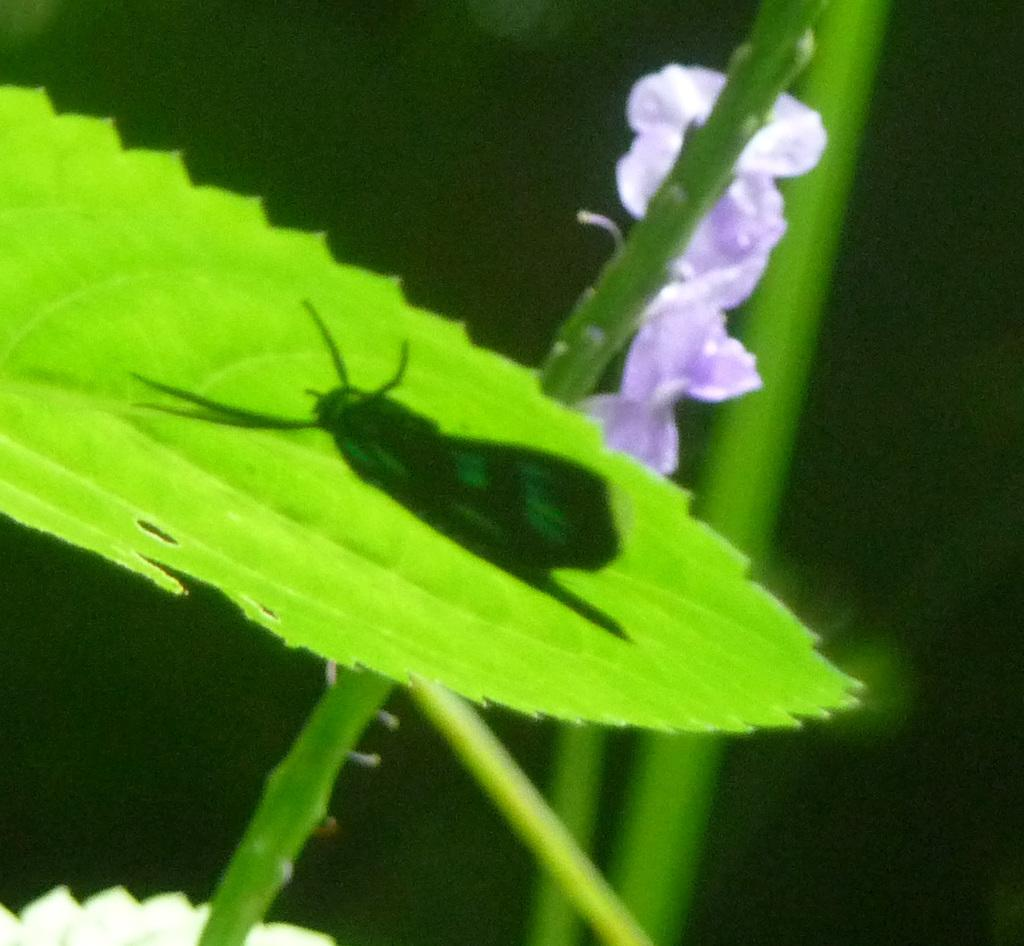What is the main subject of the image? There is an insect on a leaf in the image. What other natural elements can be seen in the image? There is a flower and stems visible in the image. What is the color of the background in the image? The background of the image is dark. What type of pipe is visible in the image? There is no pipe present in the image. How many spots can be seen on the insect in the image? There is no mention of spots on the insect in the image, so it cannot be determined from the provided facts. 